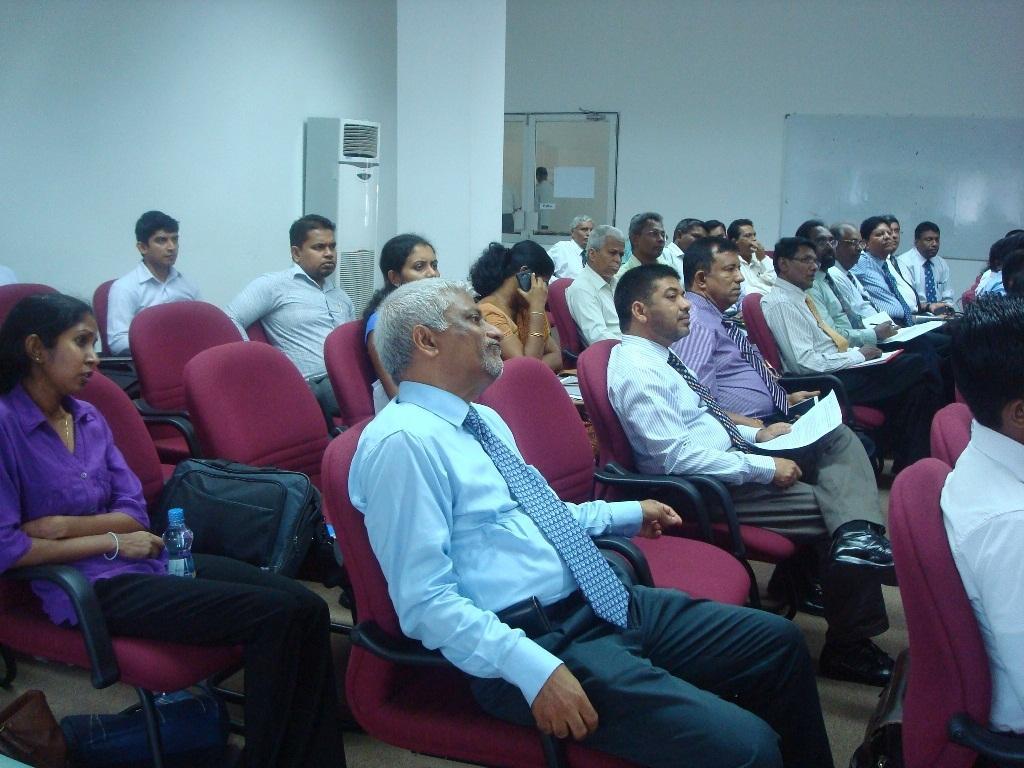Could you give a brief overview of what you see in this image? In this image we can see people sitting on the chairs. In the background we can see air conditioner and windows. 